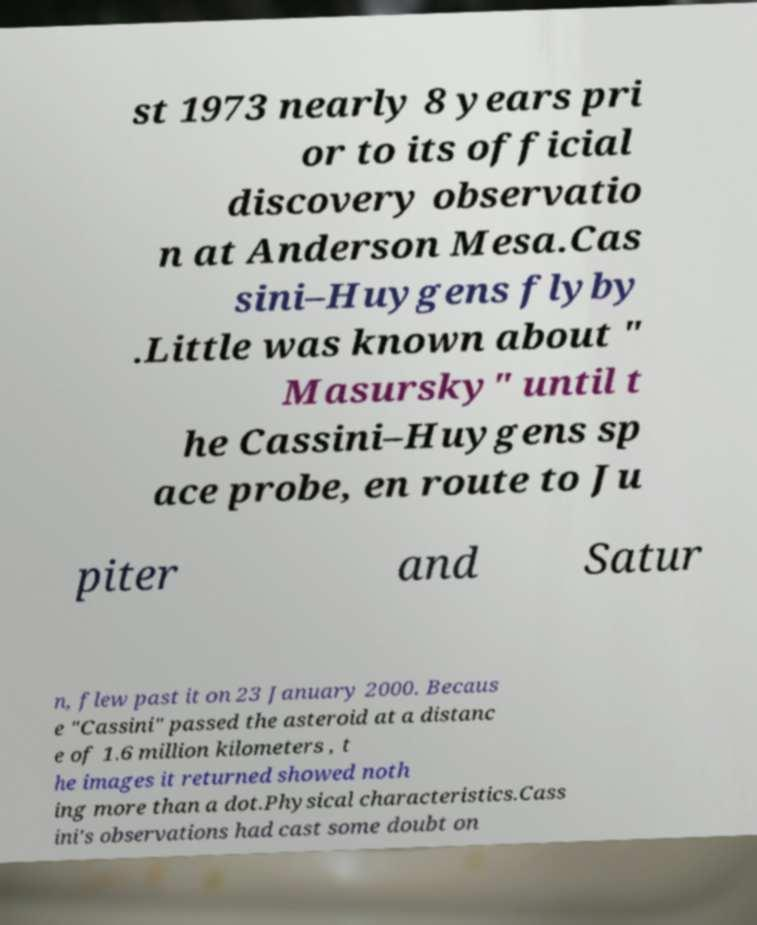Please read and relay the text visible in this image. What does it say? st 1973 nearly 8 years pri or to its official discovery observatio n at Anderson Mesa.Cas sini–Huygens flyby .Little was known about " Masursky" until t he Cassini–Huygens sp ace probe, en route to Ju piter and Satur n, flew past it on 23 January 2000. Becaus e "Cassini" passed the asteroid at a distanc e of 1.6 million kilometers , t he images it returned showed noth ing more than a dot.Physical characteristics.Cass ini's observations had cast some doubt on 